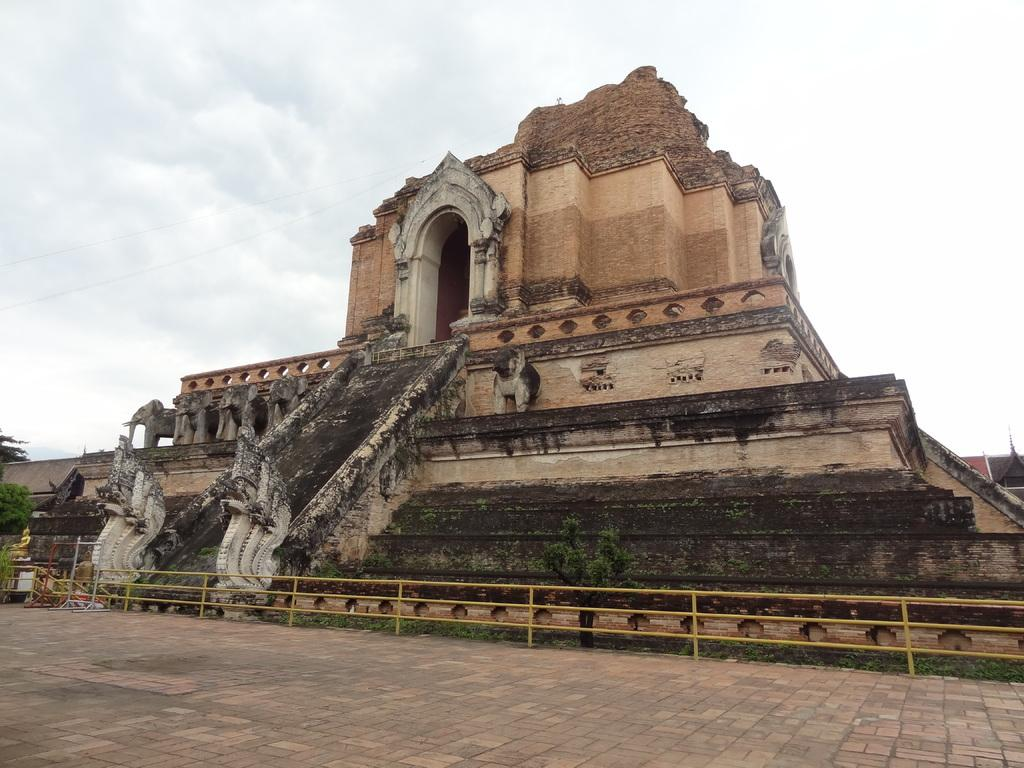What is the main structure in the image? There is a monument in the image. What is located in front of the monument? There are metal rods in front of the monument. What type of natural elements can be seen in the image? There are trees in the image. What is visible in the sky in the image? Clouds are visible in the image. How many people are running around the monument in the image? There are no people running around the monument in the image. What type of metal is used to construct the monument in the image? The provided facts do not specify the type of metal used to construct the monument. 